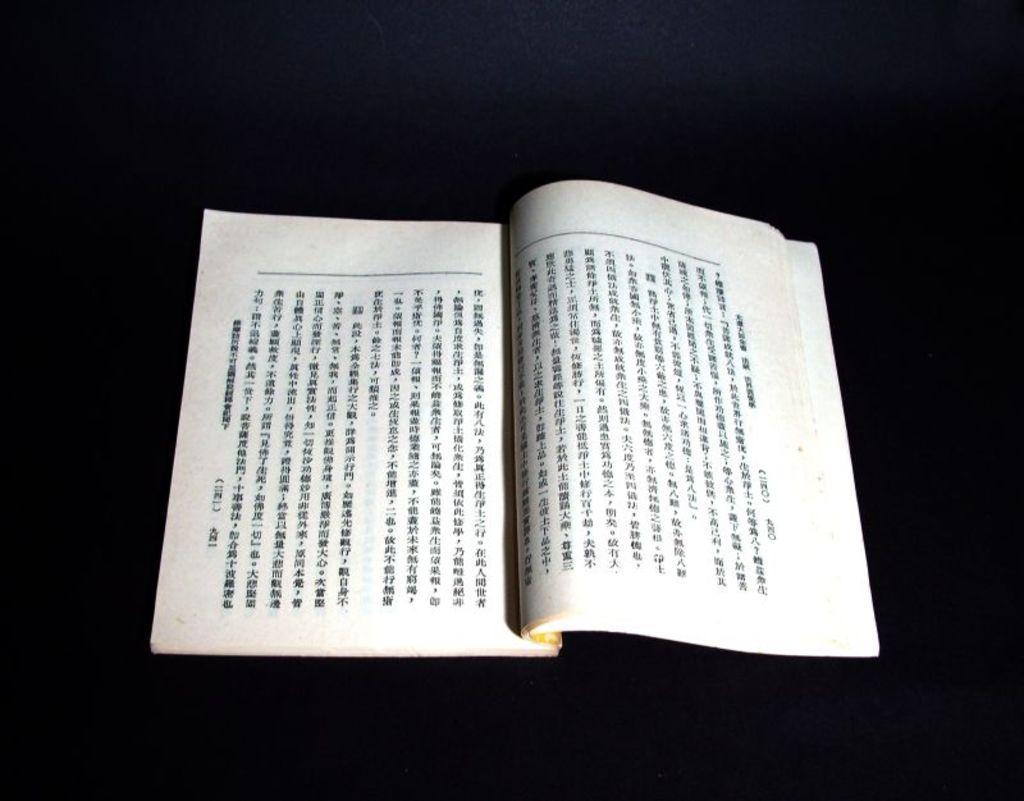In one or two sentences, can you explain what this image depicts? In the center of the image we can see one book. On the book, we can see some text. And we can see the black color background. 